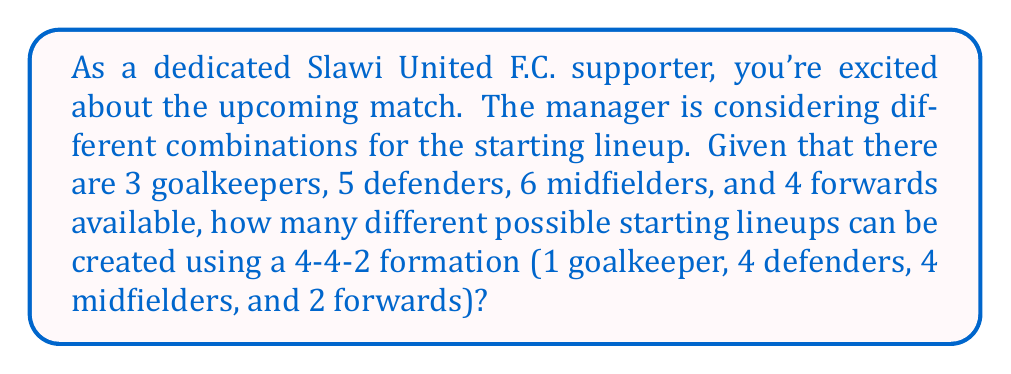Provide a solution to this math problem. Let's approach this step-by-step using the Cartesian product:

1) First, we need to choose players for each position:
   - 1 goalkeeper from 3 available: $C_1 = 3$
   - 4 defenders from 5 available: $C_2 = \binom{5}{4}$
   - 4 midfielders from 6 available: $C_3 = \binom{6}{4}$
   - 2 forwards from 4 available: $C_4 = \binom{4}{2}$

2) Calculate each combination:
   $C_1 = 3$
   $C_2 = \binom{5}{4} = \frac{5!}{4!(5-4)!} = \frac{5!}{4!1!} = 5$
   $C_3 = \binom{6}{4} = \frac{6!}{4!(6-4)!} = \frac{6!}{4!2!} = 15$
   $C_4 = \binom{4}{2} = \frac{4!}{2!(4-2)!} = \frac{4!}{2!2!} = 6$

3) The total number of possible lineups is the Cartesian product of these combinations:

   $$\text{Total Lineups} = C_1 \times C_2 \times C_3 \times C_4$$

4) Substitute the values:

   $$\text{Total Lineups} = 3 \times 5 \times 15 \times 6$$

5) Calculate the final result:

   $$\text{Total Lineups} = 1,350$$

Therefore, the manager of Slawi United F.C. can create 1,350 different possible starting lineups using the available players in a 4-4-2 formation.
Answer: 1,350 possible starting lineups 